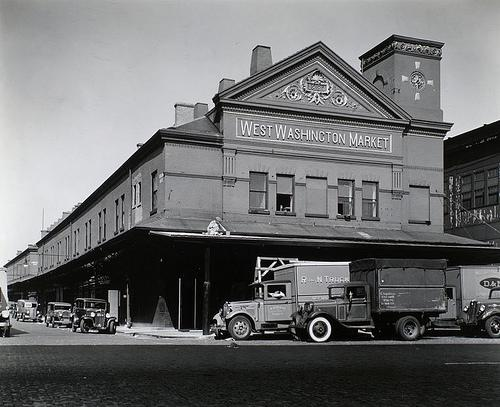Where are the trucks headed to? market 